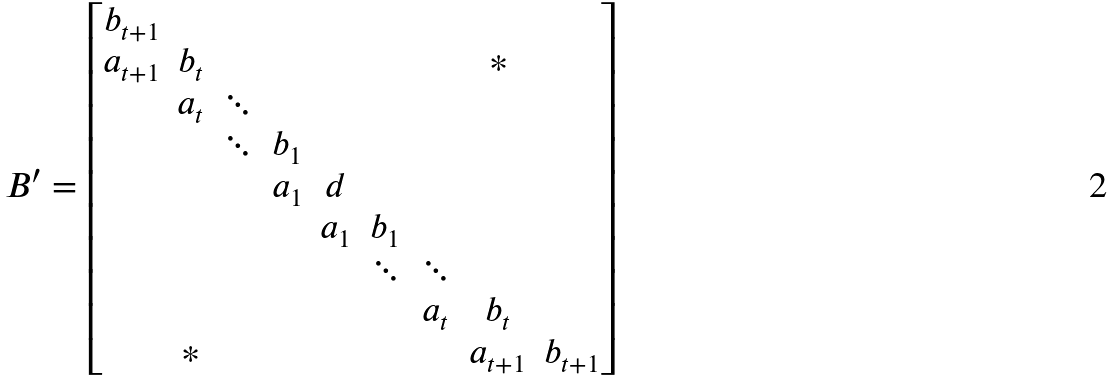Convert formula to latex. <formula><loc_0><loc_0><loc_500><loc_500>B ^ { \prime } = \begin{bmatrix} b _ { t + 1 } \\ a _ { t + 1 } & b _ { t } & & & & & & * \\ & a _ { t } & \ddots \\ & & \ddots & b _ { 1 } \\ & & & a _ { 1 } & d \\ & & & & a _ { 1 } & b _ { 1 } & & \\ & & & & & \ddots & \ddots & \\ & & & & & & a _ { t } & b _ { t } \\ & * & & & & & & a _ { t + 1 } & b _ { t + 1 } \end{bmatrix}</formula> 